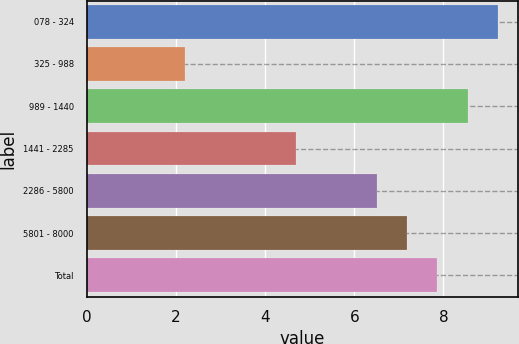Convert chart. <chart><loc_0><loc_0><loc_500><loc_500><bar_chart><fcel>078 - 324<fcel>325 - 988<fcel>989 - 1440<fcel>1441 - 2285<fcel>2286 - 5800<fcel>5801 - 8000<fcel>Total<nl><fcel>9.22<fcel>2.2<fcel>8.54<fcel>4.7<fcel>6.5<fcel>7.18<fcel>7.86<nl></chart> 